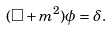<formula> <loc_0><loc_0><loc_500><loc_500>( \Box + m ^ { 2 } ) \phi = \delta .</formula> 